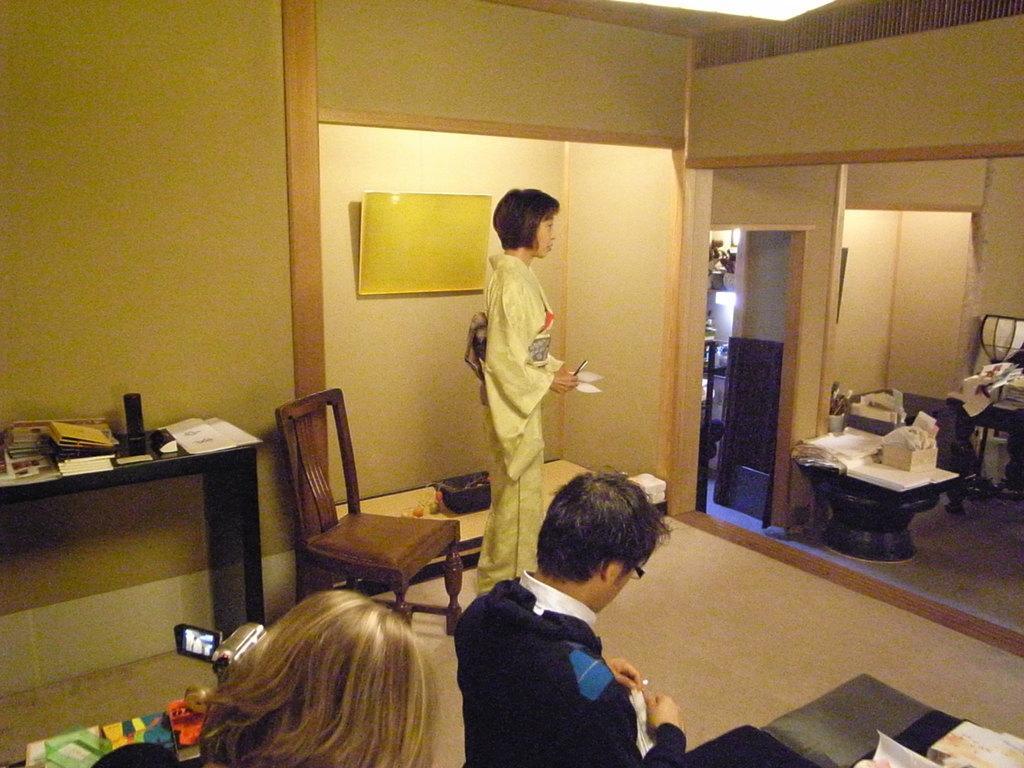Describe this image in one or two sentences. Here we can see a man and a woman. This is a chair and this looks like a statue. 